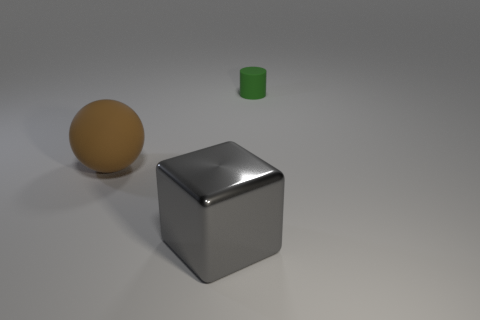Are there any other things that have the same size as the cylinder?
Provide a succinct answer. No. Is there anything else that has the same material as the big gray thing?
Offer a terse response. No. Is the color of the sphere the same as the metal block?
Make the answer very short. No. How many metal objects are either small objects or gray things?
Make the answer very short. 1. What number of things are there?
Make the answer very short. 3. Is the material of the brown ball on the left side of the gray cube the same as the large object that is in front of the brown matte sphere?
Your answer should be compact. No. The object in front of the matte thing on the left side of the green rubber object is made of what material?
Provide a succinct answer. Metal. There is a object that is behind the sphere; is its shape the same as the rubber object that is to the left of the tiny green thing?
Give a very brief answer. No. There is a thing that is both right of the matte sphere and behind the big shiny object; how big is it?
Provide a succinct answer. Small. How many other objects are there of the same color as the big matte object?
Ensure brevity in your answer.  0. 